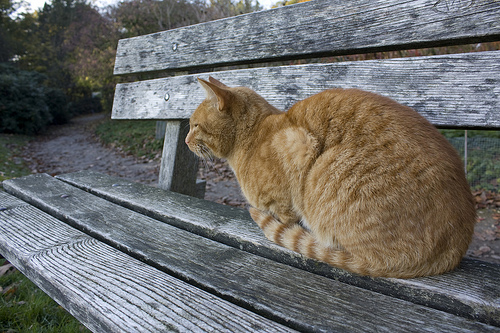What animal is on the bench? There is a cat sitting comfortably on the bench. 